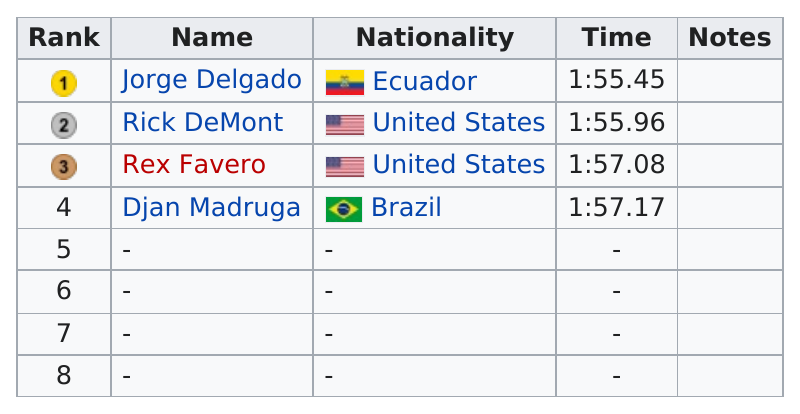List a handful of essential elements in this visual. What comes after Rex F.? Djan Madruga. It took Jorge Delgado 1 minute and 55 seconds to finish the task. The average time is 1 hour and 56 minutes and 42 seconds. The time for each name is 1 hour and 55 minutes and 45 seconds, 1 hour and 55 minutes and 96 seconds, 1 hour and 57 minutes and 8 seconds, and 1 hour and 57 minutes and 17 seconds. Rex Favero was the last finisher from the United States. 